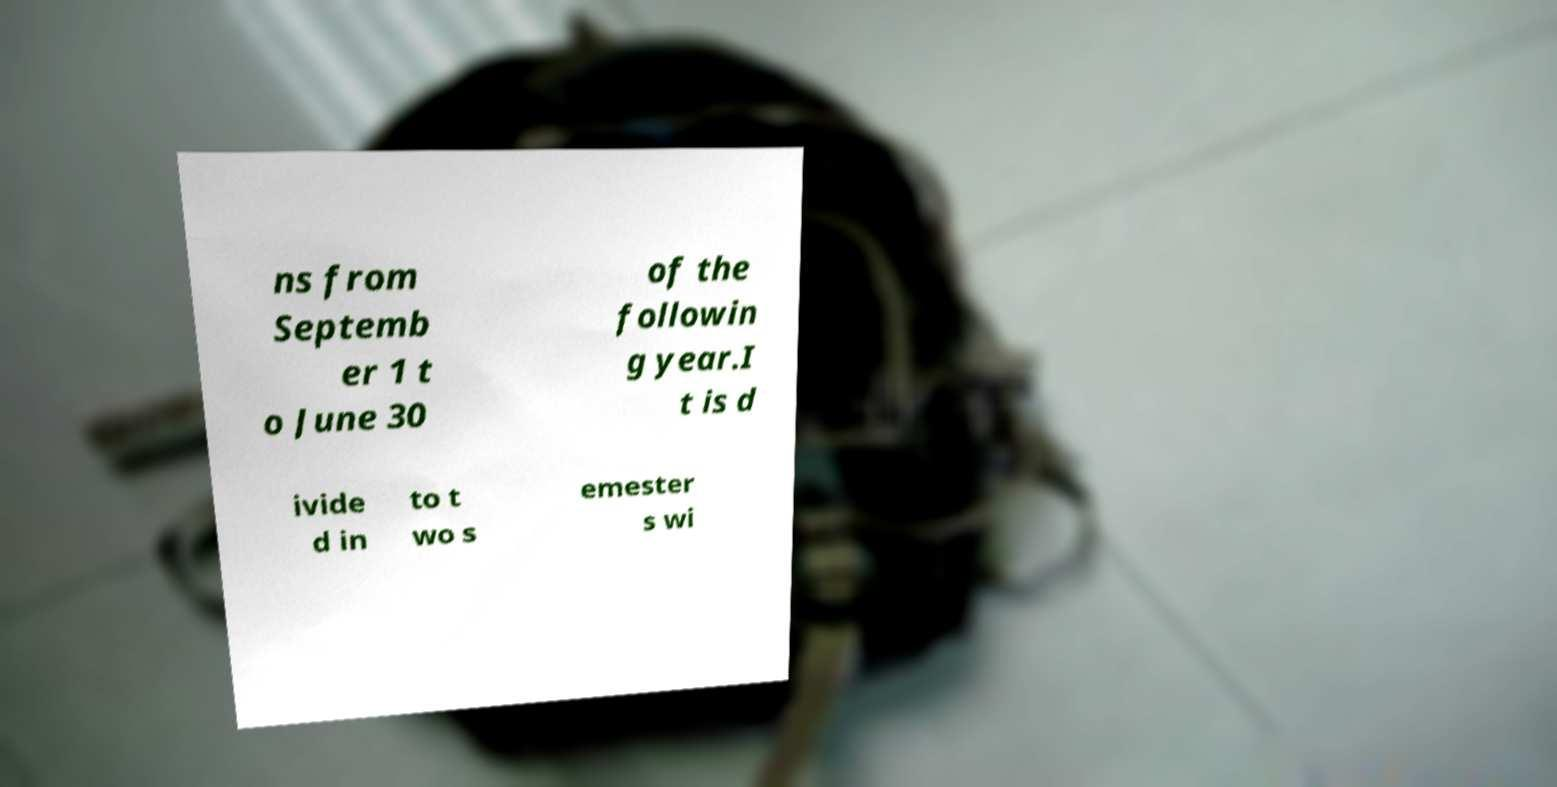Could you assist in decoding the text presented in this image and type it out clearly? ns from Septemb er 1 t o June 30 of the followin g year.I t is d ivide d in to t wo s emester s wi 